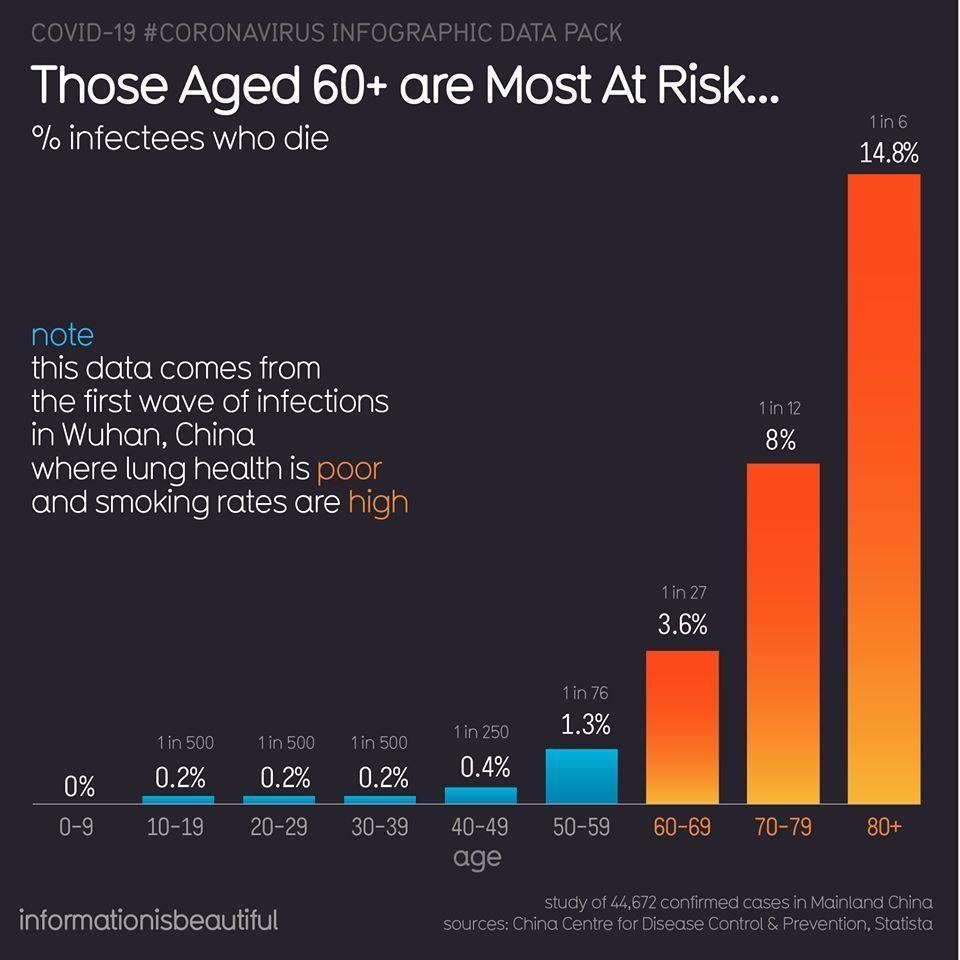In which age group is the ratio of deaths in infected people 1 in 27?
Answer the question with a short phrase. 60-69 What is the ratio of people dying in the 70-79 age group? 1 in 12 1 in 6 of people who die of coronavirus are in which age group? 80+ 